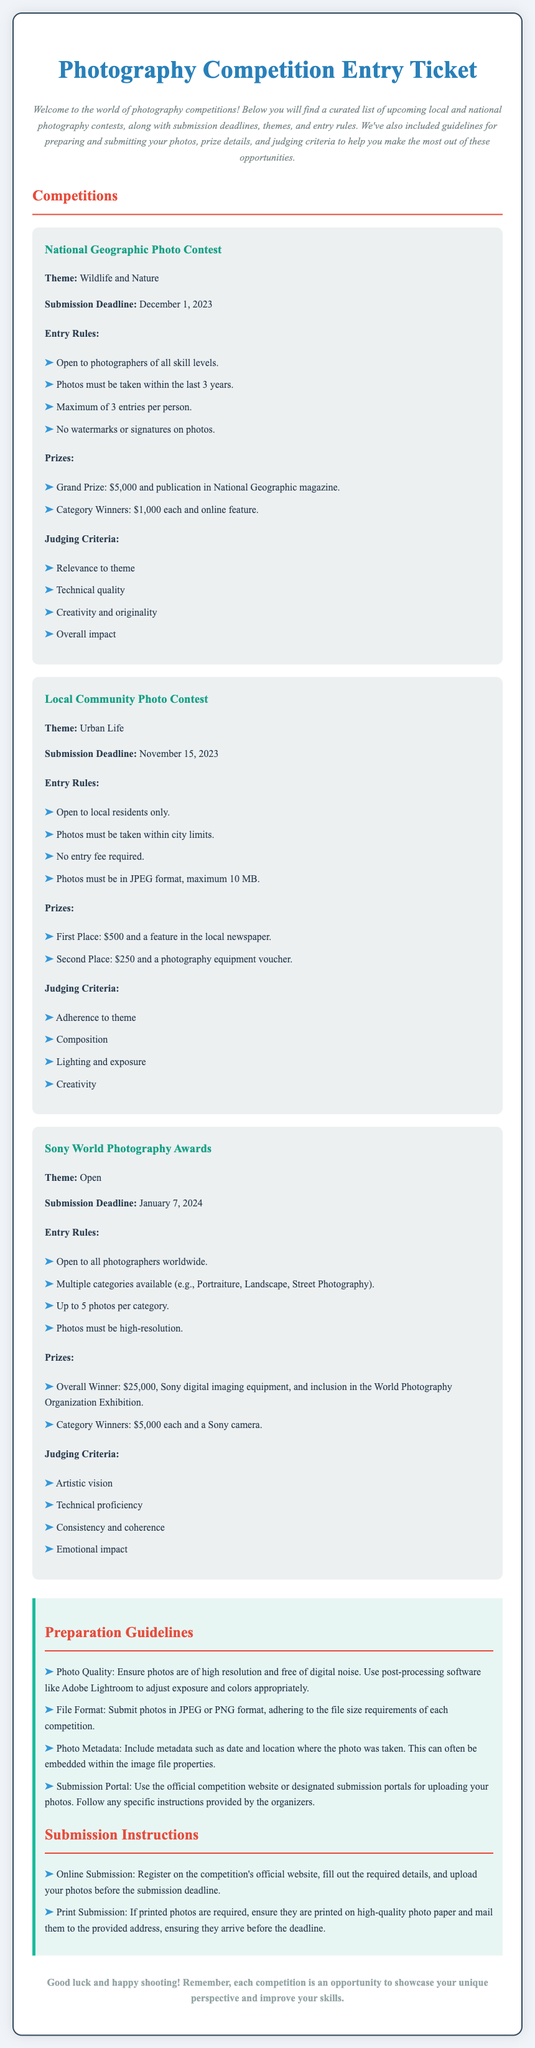What is the theme of the National Geographic Photo Contest? The theme for this contest is specified in the document as "Wildlife and Nature."
Answer: Wildlife and Nature What is the submission deadline for the Local Community Photo Contest? The document states that the submission deadline for this contest is November 15, 2023.
Answer: November 15, 2023 What is the maximum number of entries allowed for the National Geographic Photo Contest? The document mentions that the maximum number of entries per person for this contest is 3.
Answer: 3 What is the prize for the Overall Winner of the Sony World Photography Awards? The prize details for the Overall Winner are highlighted in the document as $25,000, Sony digital imaging equipment, and inclusion in the World Photography Organization Exhibition.
Answer: $25,000, Sony digital imaging equipment, and inclusion in the World Photography Organization Exhibition What specifications must photos meet for the Local Community Photo Contest? The document outlines that photos must be taken within city limits, must be in JPEG format, and have a maximum size of 10 MB.
Answer: In JPEG format, maximum 10 MB What should be included in the photo metadata? The guidelines specify that metadata should include the date and location where the photo was taken, which can be embedded within the image file properties.
Answer: Date and location How many categories are available in the Sony World Photography Awards? The document states that there are multiple categories available, including Portraiture, Landscape, and Street Photography.
Answer: Multiple categories What is a recommended software for photo quality adjustment? The guidelines recommend using Adobe Lightroom for adjusting exposure and colors appropriately.
Answer: Adobe Lightroom 